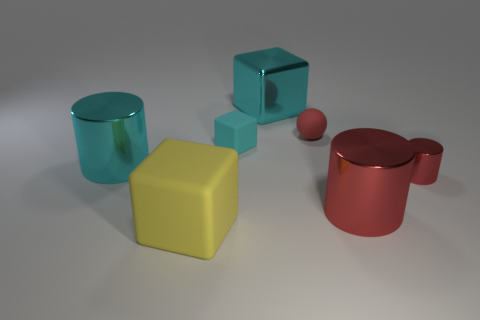What is the material of the cylinder that is the same size as the cyan rubber block?
Provide a short and direct response. Metal. Are there any cyan matte cubes that have the same size as the ball?
Offer a terse response. Yes. There is a block on the right side of the tiny cyan object; what is it made of?
Your answer should be very brief. Metal. Do the small red object that is to the right of the rubber sphere and the large red cylinder have the same material?
Provide a short and direct response. Yes. What is the shape of the cyan rubber object that is the same size as the red ball?
Offer a terse response. Cube. What number of tiny metallic cylinders have the same color as the tiny block?
Offer a terse response. 0. Is the number of tiny cyan objects that are right of the small red shiny cylinder less than the number of objects that are left of the matte ball?
Offer a very short reply. Yes. Are there any metal objects to the left of the big matte thing?
Offer a very short reply. Yes. Is there a small cyan matte thing that is in front of the small cyan object that is behind the large cyan thing that is to the left of the large matte block?
Offer a very short reply. No. There is a large red metallic object in front of the red matte ball; does it have the same shape as the tiny metallic thing?
Your response must be concise. Yes. 